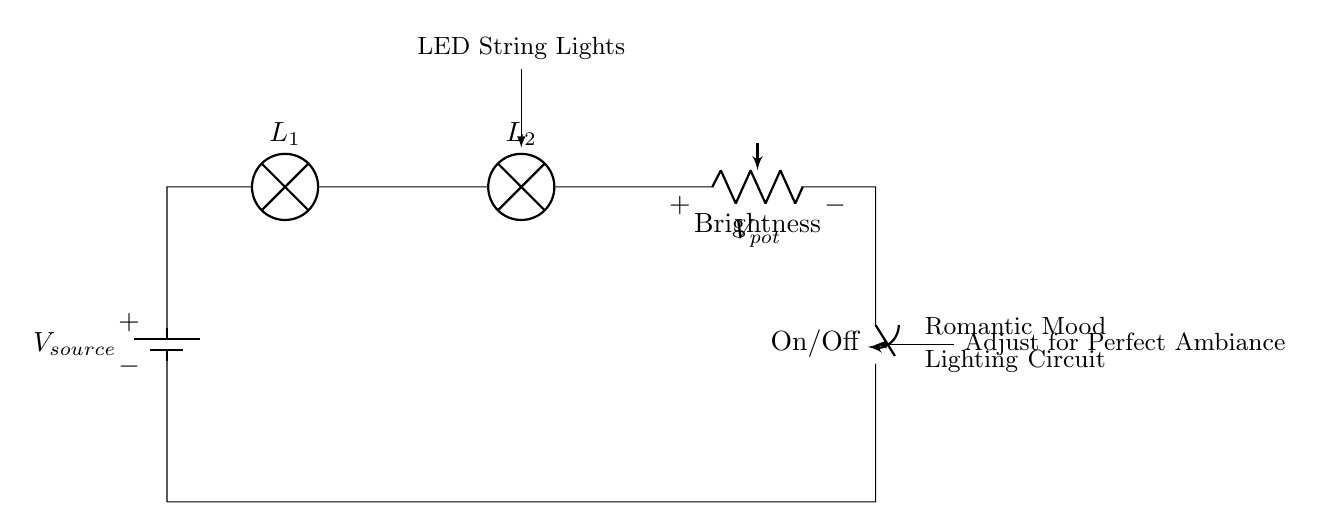What is the power source in this circuit? The power source is represented by the battery component labeled as V source, which provides the necessary electrical energy for the circuit.
Answer: V source How many lamps are in this circuit? There are two lamp components labeled L 1 and L 2 connected in series along the circuit path, indicating their presence.
Answer: 2 What component adjusts the brightness in this circuit? The brightness adjustment is achieved by the potentiometer labeled as Brightness, indicating its role in modifying the light intensity.
Answer: Brightness What type of circuit is this? The circuit is a series circuit because all the components, including the battery, lamps, potentiometer, and switch, are connected one after another, creating a single path for current flow.
Answer: Series circuit How does the switch affect the circuit? The switch labeled as On/Off can open or close the circuit; when closed, it allows current to flow, while when open, it interrupts the flow of electricity.
Answer: Opens or closes What is the purpose of the LED string lights in this circuit? The LED string lights, indicated in the diagram, serve as the source of romantic mood lighting that the circuit aims to provide, enhancing ambiance.
Answer: Mood lighting What does the potentiometer control in this system? The potentiometer controls the voltage drop across it, thus allowing the user to adjust the brightness of the lighting according to their preference.
Answer: Brightness control 